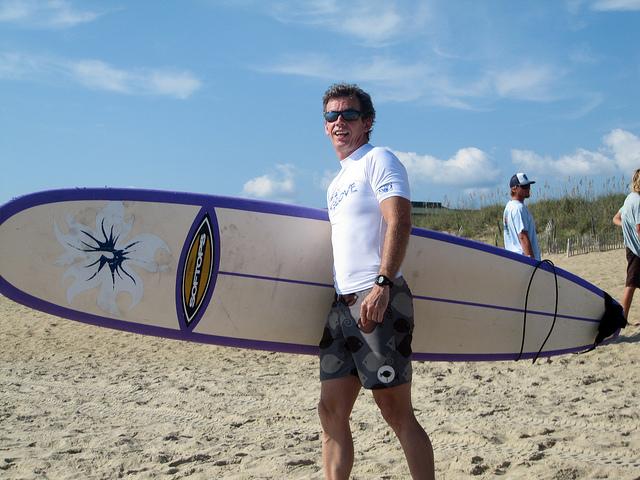Is there a man on a bike?
Answer briefly. No. How many surfboards are in the picture?
Short answer required. 1. How many men are bald?
Keep it brief. 0. What is on his left wrist?
Be succinct. Watch. Is the surfboard polished or worn?
Answer briefly. Worn. Is the man wearing a hat?
Write a very short answer. No. Where is this?
Short answer required. Beach. What is the man holding?
Be succinct. Surfboard. Is the man wearing a shirt?
Short answer required. Yes. What color is the surfboard on the right?
Write a very short answer. White. 